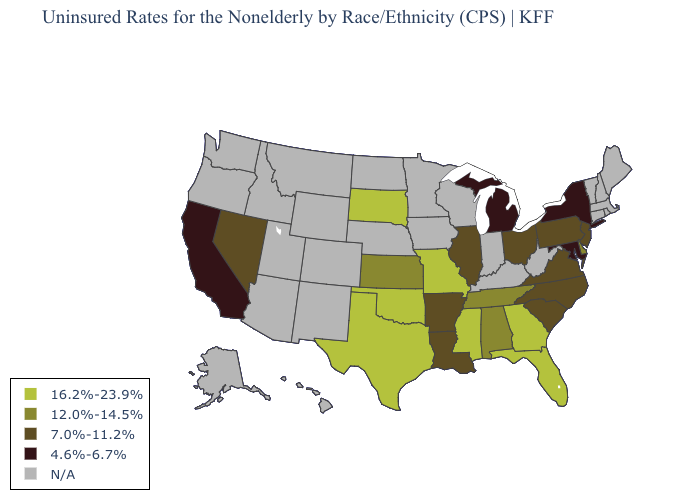Among the states that border South Carolina , which have the highest value?
Answer briefly. Georgia. What is the value of Oregon?
Write a very short answer. N/A. Name the states that have a value in the range N/A?
Quick response, please. Alaska, Arizona, Colorado, Connecticut, Hawaii, Idaho, Indiana, Iowa, Kentucky, Maine, Massachusetts, Minnesota, Montana, Nebraska, New Hampshire, New Mexico, North Dakota, Oregon, Rhode Island, Utah, Vermont, Washington, West Virginia, Wisconsin, Wyoming. Name the states that have a value in the range 4.6%-6.7%?
Short answer required. California, Maryland, Michigan, New York. Does Missouri have the highest value in the USA?
Answer briefly. Yes. What is the value of Tennessee?
Short answer required. 12.0%-14.5%. What is the value of California?
Concise answer only. 4.6%-6.7%. Name the states that have a value in the range 12.0%-14.5%?
Quick response, please. Alabama, Delaware, Kansas, Tennessee. Does the map have missing data?
Keep it brief. Yes. What is the value of Washington?
Keep it brief. N/A. Name the states that have a value in the range 16.2%-23.9%?
Short answer required. Florida, Georgia, Mississippi, Missouri, Oklahoma, South Dakota, Texas. Which states have the highest value in the USA?
Answer briefly. Florida, Georgia, Mississippi, Missouri, Oklahoma, South Dakota, Texas. What is the value of Illinois?
Keep it brief. 7.0%-11.2%. Does the first symbol in the legend represent the smallest category?
Be succinct. No. Which states have the lowest value in the West?
Be succinct. California. 